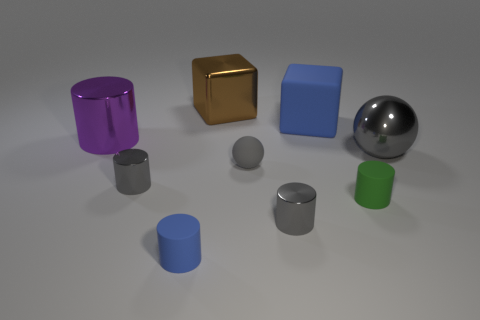Are the materials of these objects the same or different? Although it's a render and not real physical objects, the materials appear to be differentiated by their textures and colors. The gold cube seems to have a metallic sheen, the silver sphere also looks metallic, and the other objects have a matte finish. This variety in textures suggests they are intended to represent different materials. 